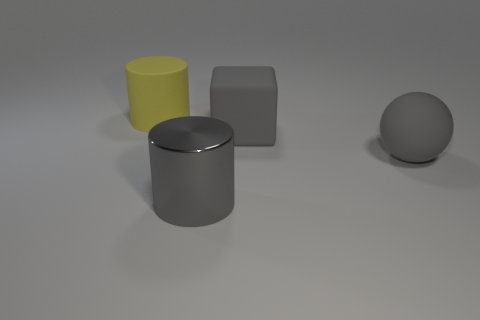There is a large cylinder that is behind the gray sphere; what is its material?
Your response must be concise. Rubber. There is a big thing on the left side of the big gray cylinder; what number of large objects are in front of it?
Your answer should be compact. 3. What number of gray things have the same shape as the yellow matte object?
Provide a succinct answer. 1. What number of large cyan rubber cylinders are there?
Ensure brevity in your answer.  0. What is the color of the rubber thing that is behind the large cube?
Provide a short and direct response. Yellow. What color is the object that is in front of the big gray matte ball that is behind the gray cylinder?
Give a very brief answer. Gray. There is a sphere that is the same size as the gray cylinder; what color is it?
Offer a terse response. Gray. How many objects are both in front of the ball and right of the large shiny cylinder?
Your answer should be compact. 0. There is a big rubber thing that is the same color as the ball; what is its shape?
Provide a short and direct response. Cube. There is a large thing that is behind the big metallic object and on the left side of the rubber cube; what material is it?
Provide a short and direct response. Rubber. 